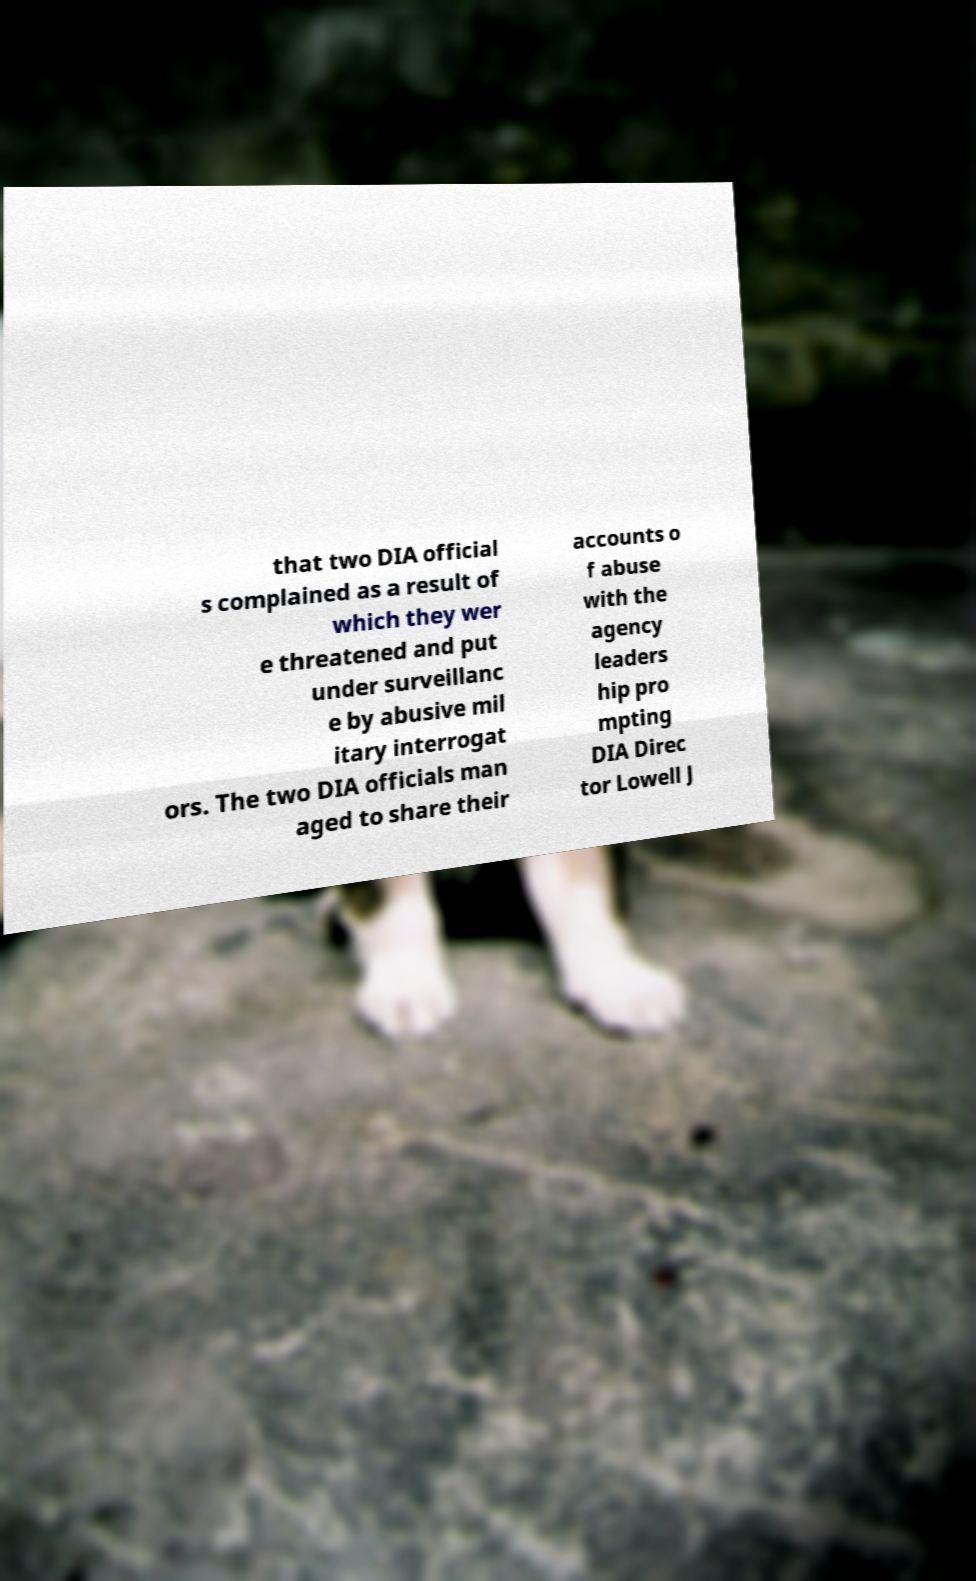There's text embedded in this image that I need extracted. Can you transcribe it verbatim? that two DIA official s complained as a result of which they wer e threatened and put under surveillanc e by abusive mil itary interrogat ors. The two DIA officials man aged to share their accounts o f abuse with the agency leaders hip pro mpting DIA Direc tor Lowell J 